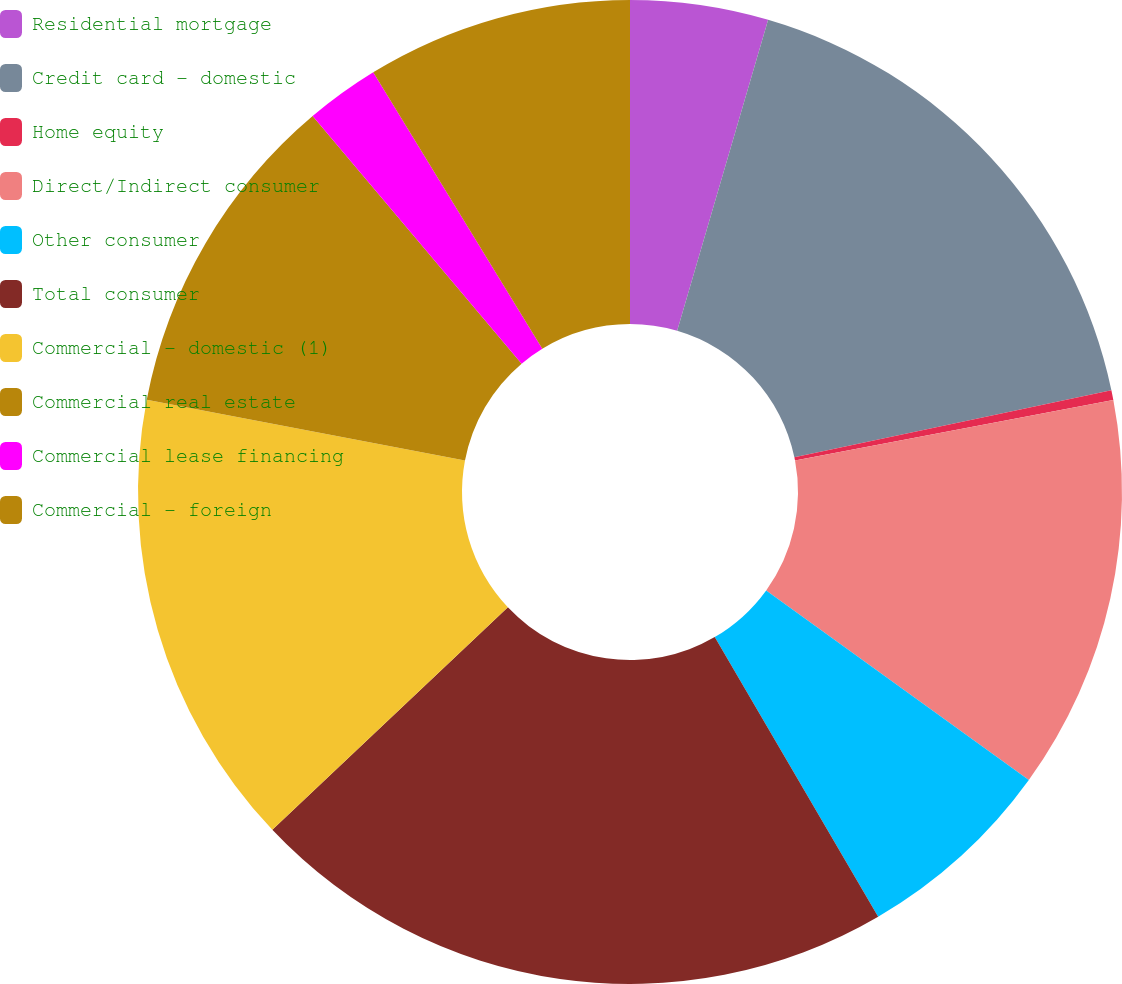Convert chart to OTSL. <chart><loc_0><loc_0><loc_500><loc_500><pie_chart><fcel>Residential mortgage<fcel>Credit card - domestic<fcel>Home equity<fcel>Direct/Indirect consumer<fcel>Other consumer<fcel>Total consumer<fcel>Commercial - domestic (1)<fcel>Commercial real estate<fcel>Commercial lease financing<fcel>Commercial - foreign<nl><fcel>4.53%<fcel>17.16%<fcel>0.32%<fcel>12.95%<fcel>6.63%<fcel>21.37%<fcel>15.05%<fcel>10.84%<fcel>2.42%<fcel>8.74%<nl></chart> 